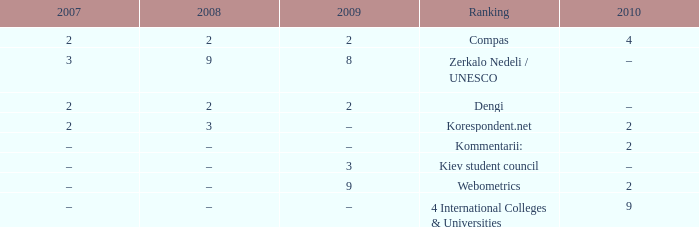What was the 2009 ranking for Webometrics? 9.0. 